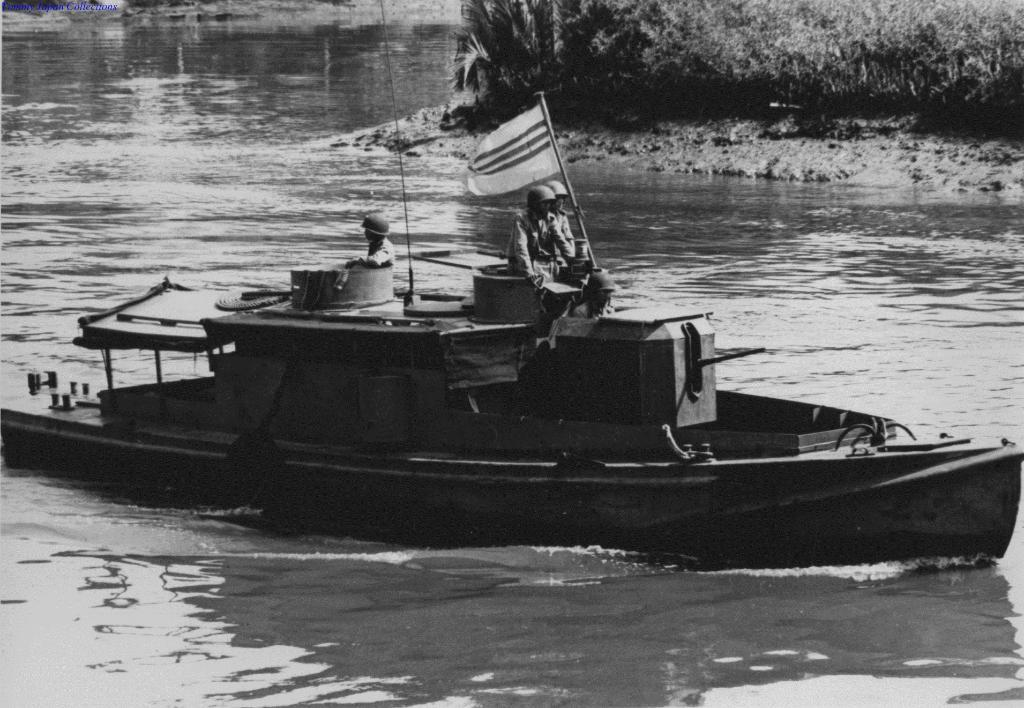What is happening in the image involving the three persons? The three persons are on a boat in the water. What can be seen in the foreground of the image? There is a flag pole in the foreground. What type of vegetation is visible in the background? Grass and trees are present in the background. What type of body of water might the image have been taken at? The image may have been taken at a lake. What type of health advice is the fireman giving to the persons on the boat in the image? There is no fireman present in the image, and therefore no health advice can be given. What is the stick used for in the image? There is no stick present in the image. 